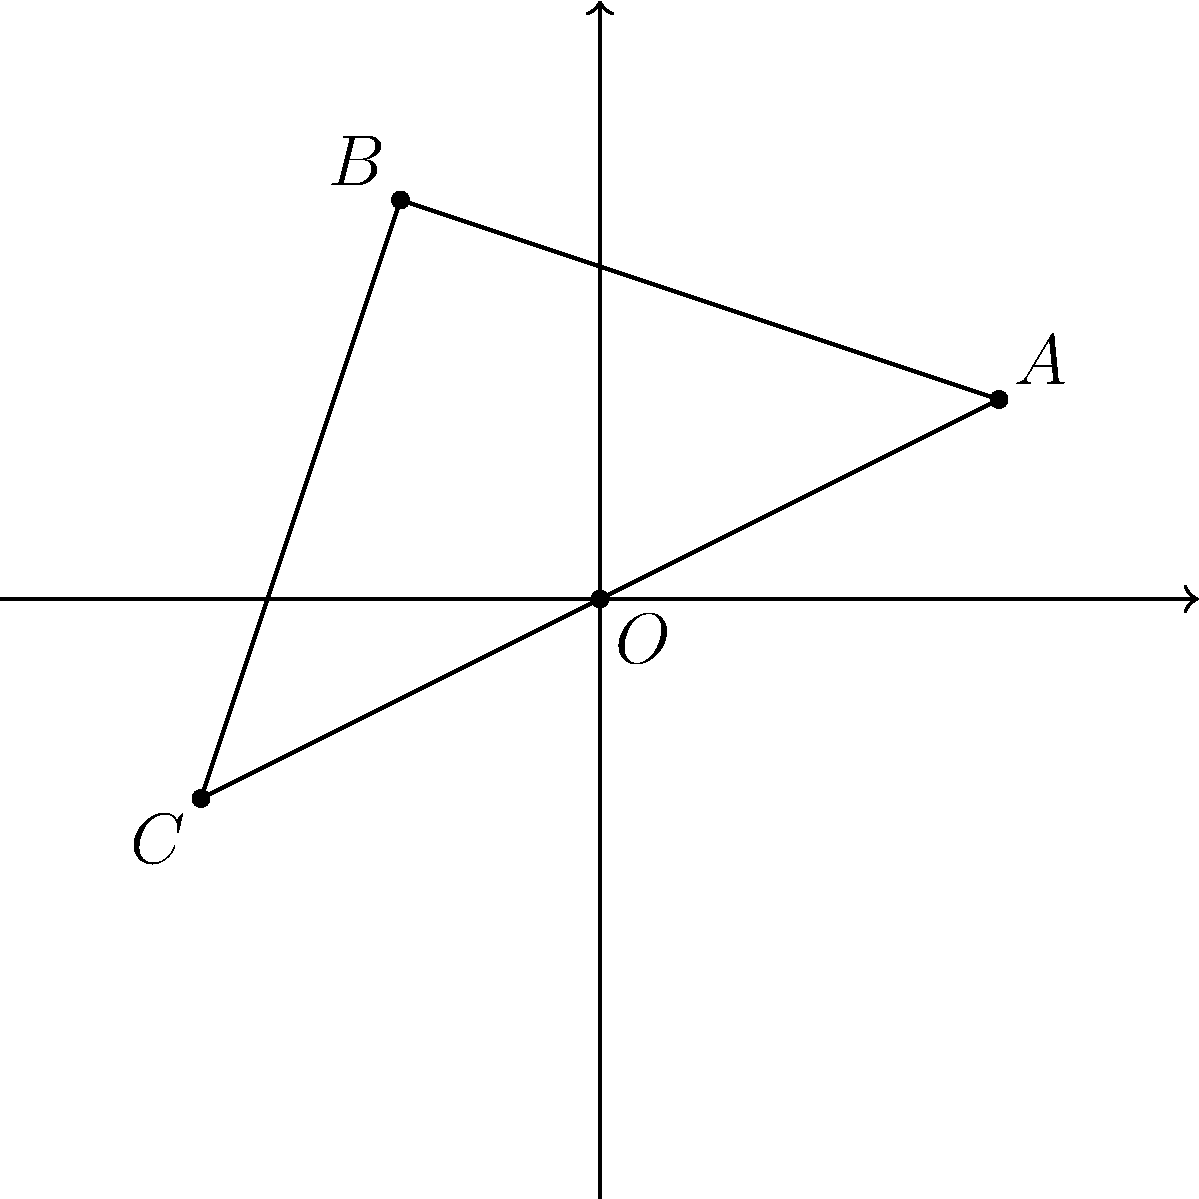In a film set, a director is experimenting with camera angles to create a symmetrical shot. The camera positions form a quadrilateral OABC, where O is the origin (0,0). If the director wants to reflect this setup across the y-axis to achieve perfect symmetry, what will be the coordinates of point A' (the reflection of point A)? To solve this problem, we need to follow these steps:

1. Identify the coordinates of point A: From the diagram, we can see that A is located at (2,1).

2. Understand the reflection process: When reflecting a point across the y-axis, the x-coordinate changes sign while the y-coordinate remains the same.

3. Apply the reflection:
   - The x-coordinate of A is 2. After reflection, it becomes -2.
   - The y-coordinate of A is 1. It remains 1 after reflection.

4. Therefore, the coordinates of A' are (-2,1).

This reflection process is crucial in cinematography for creating visually balanced and symmetrical shots, which can evoke certain emotions or emphasize themes in film direction.
Answer: (-2,1) 